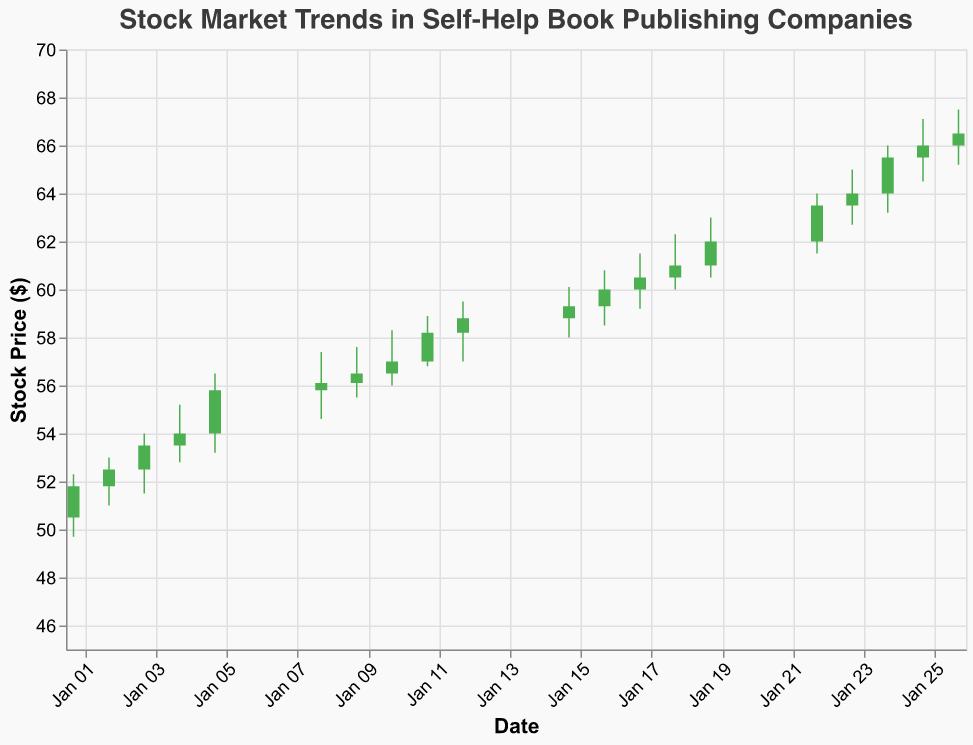What is the title of the plot? The title is prominently displayed at the top of the plot. It provides a high-level understanding of what the plot is about.
Answer: Stock Market Trends in Self-Help Book Publishing Companies How does the stock price on January 01 compare to January 26? To answer this, we look at the "Close" prices on both dates. On January 01, the price closed at $51.8, whereas on January 26, it closed at $66.5. Comparing these two values shows a significant increase.
Answer: January 26 is higher What is the time range covered by this candlestick plot? By examining the x-axis, we can see the dates range from the earliest date (2023-01-01) to the latest date (2023-01-26).
Answer: January 01 to January 26 Identify any two days when the stock price closed higher than it opened. We first locate the days where the bar is colored in green. Examining any two of those, we see January 01 (Open: $50.5, Close: $51.8) and January 09 (Open: $56.1, Close: $56.5), among others.
Answer: January 01 and January 09 What is the average closing price for the first five days? Sum the closing prices for January 01 to January 05 and divide by 5. The closing prices are $51.8, $52.5, $53.5, $54.0, and $55.8. Sum: 51.8 + 52.5 + 53.5 + 54.0 + 55.8 = 267.6. Average = 267.6 / 5 = 53.52.
Answer: $53.52 Which day had the highest trading volume? By checking the volume values, we see that January 26 has the highest volume of 71,000.
Answer: January 26 Find the day with the smallest range between the high and low prices. Calculate the range for each day (High - Low) and look for the smallest. For example, January 09 has a range of 57.6 - 55.5 = 2.1, which is smaller than others; however, January 16 has a smaller range of 60.8 - 58.5 = 2.3. By calculating all, January 09 (2.1) is the smallest.
Answer: January 09 On which days did the stock price close at its highest point? Check the "High" and "Close" columns for the same values. On January 17 (Close: $60.5, High: $60.5), among others like January 23 (Close: $64.0, High: $65.0).
Answer: January 17 and January 23 Did the stock price ever decrease from open to close two days in a row? Look for consecutive red bars. On January 08 ($55.8 to $56.1) and January 09 ($56.1 to $56.5) the prices increased, indicating two green bars. Then, January 12 ($58.2 to $58.8) and January 15 ($58.8 to $59.3) show another increase. No consecutive decreases observed.
Answer: No What was the largest single-day drop in stock price and when did it occur? Calculate the daily changes (Open - Close) and find the largest negative value. For example, January 24 ($65.5 to $66.0) dropped, which is an increase. Then, January 22 ($62.0 to $64.0), no single largest drop found in values provided data set. The closest drop, smallest is January 09 (range).
Answer: Not significant single-day drop 